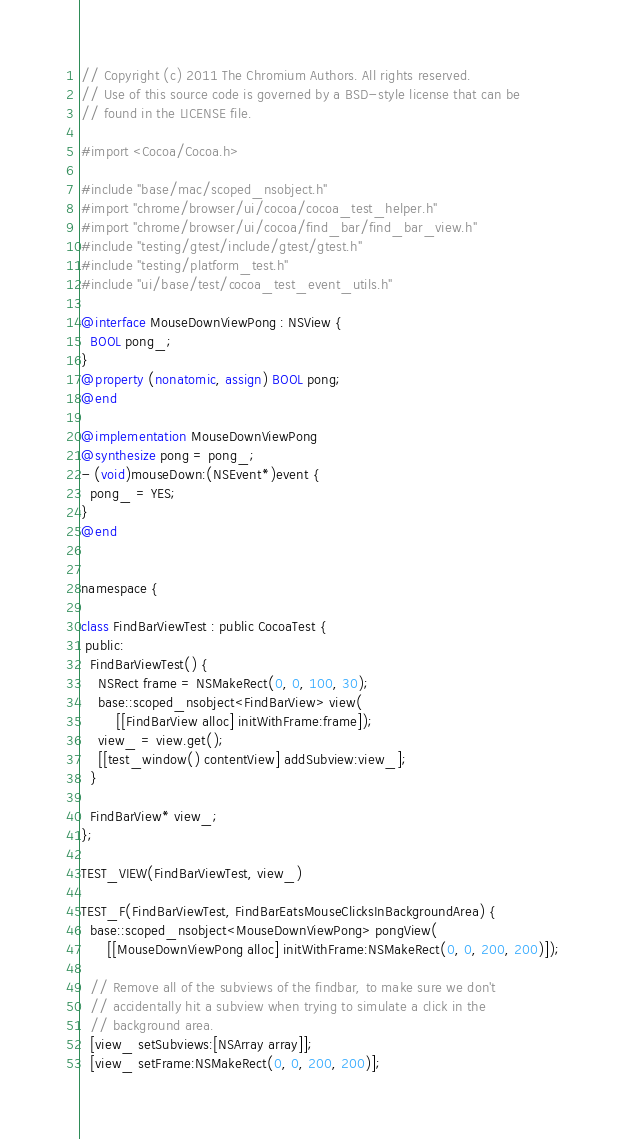<code> <loc_0><loc_0><loc_500><loc_500><_ObjectiveC_>// Copyright (c) 2011 The Chromium Authors. All rights reserved.
// Use of this source code is governed by a BSD-style license that can be
// found in the LICENSE file.

#import <Cocoa/Cocoa.h>

#include "base/mac/scoped_nsobject.h"
#import "chrome/browser/ui/cocoa/cocoa_test_helper.h"
#import "chrome/browser/ui/cocoa/find_bar/find_bar_view.h"
#include "testing/gtest/include/gtest/gtest.h"
#include "testing/platform_test.h"
#include "ui/base/test/cocoa_test_event_utils.h"

@interface MouseDownViewPong : NSView {
  BOOL pong_;
}
@property (nonatomic, assign) BOOL pong;
@end

@implementation MouseDownViewPong
@synthesize pong = pong_;
- (void)mouseDown:(NSEvent*)event {
  pong_ = YES;
}
@end


namespace {

class FindBarViewTest : public CocoaTest {
 public:
  FindBarViewTest() {
    NSRect frame = NSMakeRect(0, 0, 100, 30);
    base::scoped_nsobject<FindBarView> view(
        [[FindBarView alloc] initWithFrame:frame]);
    view_ = view.get();
    [[test_window() contentView] addSubview:view_];
  }

  FindBarView* view_;
};

TEST_VIEW(FindBarViewTest, view_)

TEST_F(FindBarViewTest, FindBarEatsMouseClicksInBackgroundArea) {
  base::scoped_nsobject<MouseDownViewPong> pongView(
      [[MouseDownViewPong alloc] initWithFrame:NSMakeRect(0, 0, 200, 200)]);

  // Remove all of the subviews of the findbar, to make sure we don't
  // accidentally hit a subview when trying to simulate a click in the
  // background area.
  [view_ setSubviews:[NSArray array]];
  [view_ setFrame:NSMakeRect(0, 0, 200, 200)];
</code> 